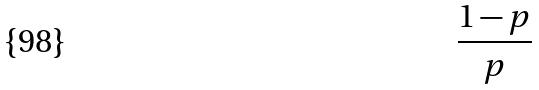<formula> <loc_0><loc_0><loc_500><loc_500>\frac { 1 - p } { p }</formula> 